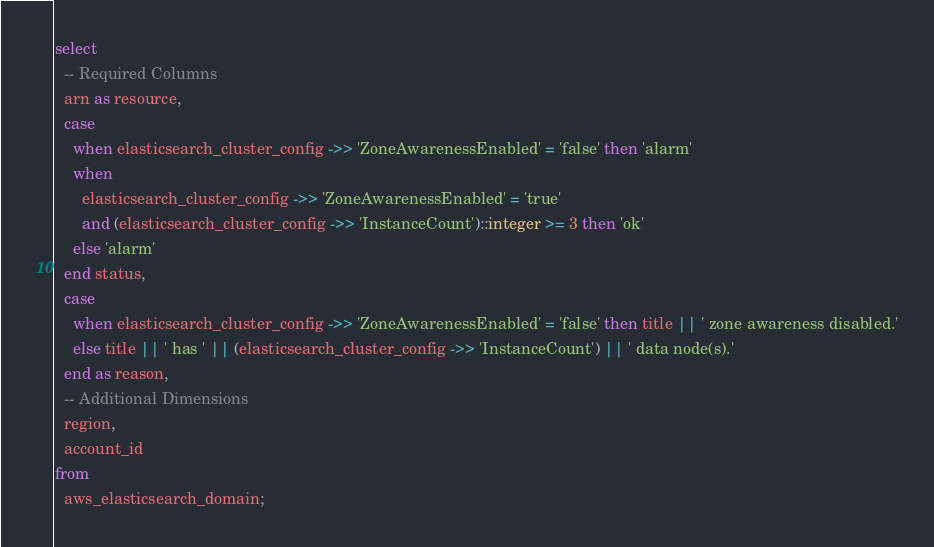Convert code to text. <code><loc_0><loc_0><loc_500><loc_500><_SQL_>select
  -- Required Columns
  arn as resource,
  case
    when elasticsearch_cluster_config ->> 'ZoneAwarenessEnabled' = 'false' then 'alarm'
    when
      elasticsearch_cluster_config ->> 'ZoneAwarenessEnabled' = 'true'
      and (elasticsearch_cluster_config ->> 'InstanceCount')::integer >= 3 then 'ok'
    else 'alarm'
  end status,
  case
    when elasticsearch_cluster_config ->> 'ZoneAwarenessEnabled' = 'false' then title || ' zone awareness disabled.'
    else title || ' has ' || (elasticsearch_cluster_config ->> 'InstanceCount') || ' data node(s).'
  end as reason,
  -- Additional Dimensions
  region,
  account_id
from
  aws_elasticsearch_domain;</code> 